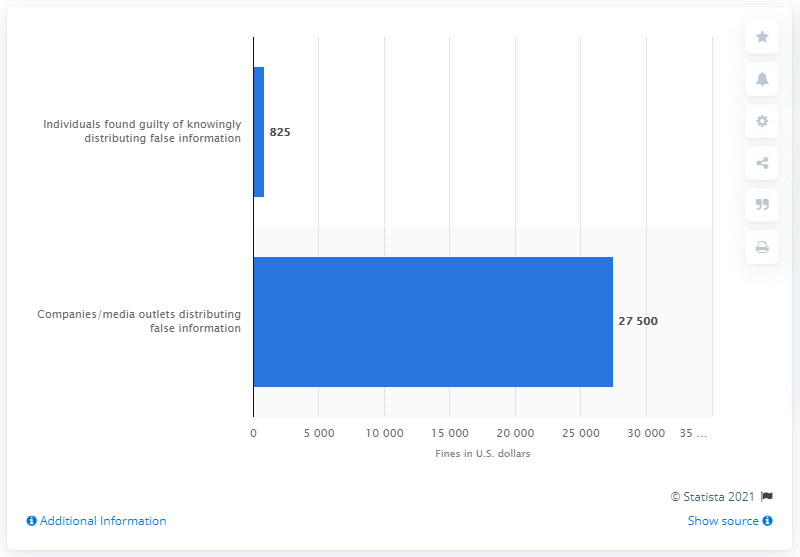Specify some key components in this picture. The fines for companies and media outlets for lying or spreading false information online could potentially reach 27,500. A proposed bill in Nigeria would fine individuals up to 825 for lying or spreading false information on social media. 